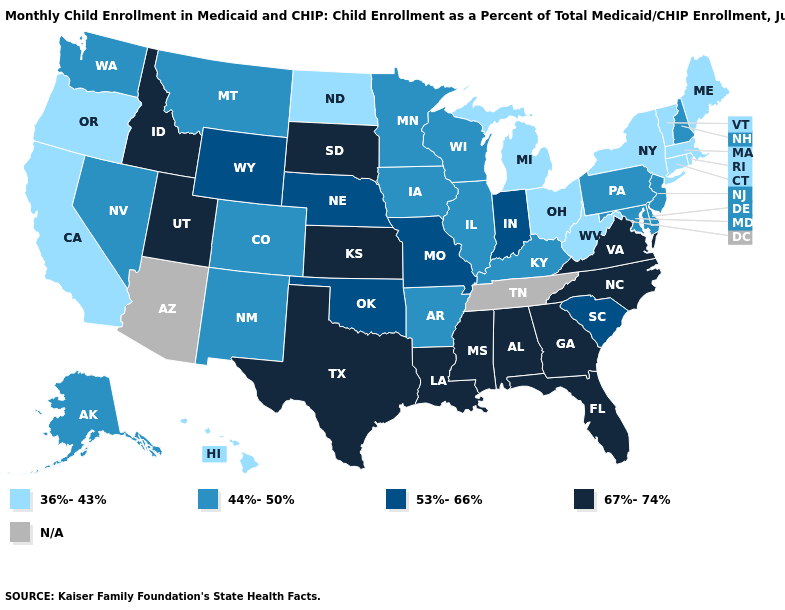Which states have the lowest value in the USA?
Short answer required. California, Connecticut, Hawaii, Maine, Massachusetts, Michigan, New York, North Dakota, Ohio, Oregon, Rhode Island, Vermont, West Virginia. What is the value of North Dakota?
Short answer required. 36%-43%. What is the value of New Mexico?
Concise answer only. 44%-50%. What is the highest value in the USA?
Give a very brief answer. 67%-74%. Among the states that border Iowa , does Wisconsin have the lowest value?
Write a very short answer. Yes. Which states hav the highest value in the South?
Give a very brief answer. Alabama, Florida, Georgia, Louisiana, Mississippi, North Carolina, Texas, Virginia. What is the lowest value in the USA?
Answer briefly. 36%-43%. Which states have the lowest value in the West?
Short answer required. California, Hawaii, Oregon. Name the states that have a value in the range 44%-50%?
Keep it brief. Alaska, Arkansas, Colorado, Delaware, Illinois, Iowa, Kentucky, Maryland, Minnesota, Montana, Nevada, New Hampshire, New Jersey, New Mexico, Pennsylvania, Washington, Wisconsin. Does the first symbol in the legend represent the smallest category?
Be succinct. Yes. Does Vermont have the highest value in the Northeast?
Give a very brief answer. No. Does Kansas have the highest value in the USA?
Keep it brief. Yes. What is the lowest value in the USA?
Short answer required. 36%-43%. What is the value of South Dakota?
Concise answer only. 67%-74%. 